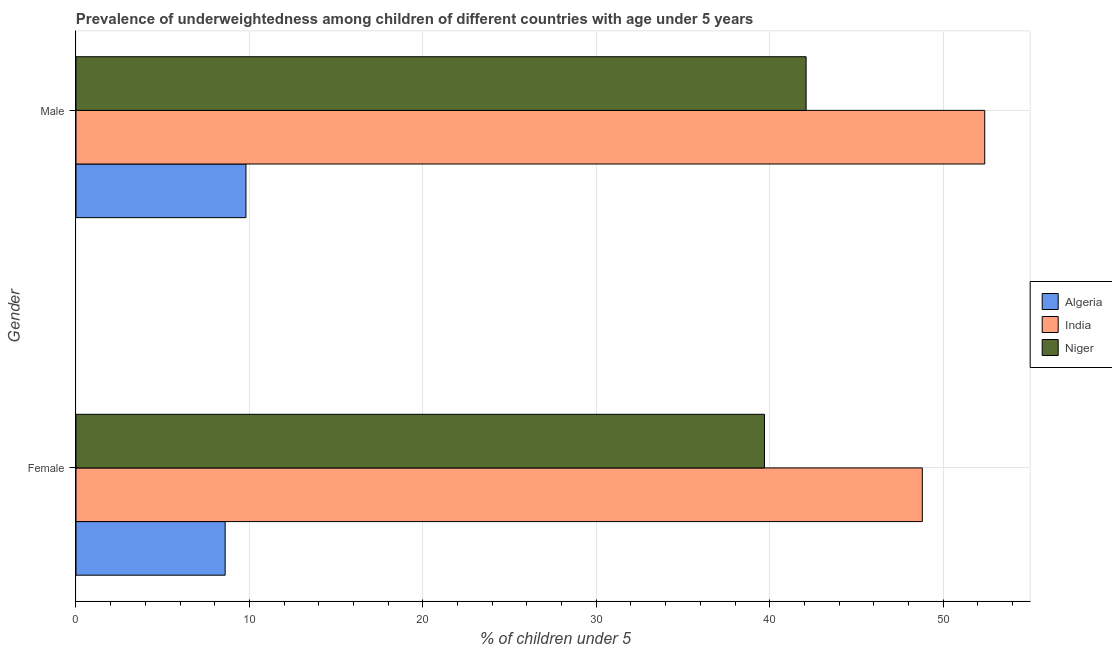How many different coloured bars are there?
Your response must be concise. 3. How many groups of bars are there?
Offer a very short reply. 2. How many bars are there on the 2nd tick from the top?
Offer a terse response. 3. How many bars are there on the 2nd tick from the bottom?
Offer a very short reply. 3. What is the label of the 1st group of bars from the top?
Offer a very short reply. Male. What is the percentage of underweighted male children in India?
Provide a succinct answer. 52.4. Across all countries, what is the maximum percentage of underweighted female children?
Give a very brief answer. 48.8. Across all countries, what is the minimum percentage of underweighted female children?
Offer a very short reply. 8.6. In which country was the percentage of underweighted female children maximum?
Your answer should be very brief. India. In which country was the percentage of underweighted female children minimum?
Your answer should be very brief. Algeria. What is the total percentage of underweighted female children in the graph?
Your answer should be compact. 97.1. What is the difference between the percentage of underweighted male children in Niger and that in India?
Your response must be concise. -10.3. What is the difference between the percentage of underweighted male children in Algeria and the percentage of underweighted female children in Niger?
Provide a succinct answer. -29.9. What is the average percentage of underweighted male children per country?
Ensure brevity in your answer.  34.77. What is the difference between the percentage of underweighted male children and percentage of underweighted female children in Algeria?
Provide a short and direct response. 1.2. In how many countries, is the percentage of underweighted male children greater than 50 %?
Your answer should be compact. 1. What is the ratio of the percentage of underweighted male children in Algeria to that in Niger?
Make the answer very short. 0.23. Is the percentage of underweighted male children in Niger less than that in Algeria?
Offer a very short reply. No. What does the 2nd bar from the bottom in Female represents?
Offer a terse response. India. How many bars are there?
Your answer should be compact. 6. How many countries are there in the graph?
Your answer should be compact. 3. What is the difference between two consecutive major ticks on the X-axis?
Offer a terse response. 10. Does the graph contain grids?
Your response must be concise. Yes. Where does the legend appear in the graph?
Provide a succinct answer. Center right. How many legend labels are there?
Ensure brevity in your answer.  3. How are the legend labels stacked?
Offer a terse response. Vertical. What is the title of the graph?
Provide a succinct answer. Prevalence of underweightedness among children of different countries with age under 5 years. Does "Bulgaria" appear as one of the legend labels in the graph?
Make the answer very short. No. What is the label or title of the X-axis?
Keep it short and to the point.  % of children under 5. What is the label or title of the Y-axis?
Provide a short and direct response. Gender. What is the  % of children under 5 of Algeria in Female?
Offer a very short reply. 8.6. What is the  % of children under 5 in India in Female?
Offer a terse response. 48.8. What is the  % of children under 5 in Niger in Female?
Your answer should be very brief. 39.7. What is the  % of children under 5 of Algeria in Male?
Offer a terse response. 9.8. What is the  % of children under 5 of India in Male?
Your answer should be compact. 52.4. What is the  % of children under 5 in Niger in Male?
Keep it short and to the point. 42.1. Across all Gender, what is the maximum  % of children under 5 of Algeria?
Keep it short and to the point. 9.8. Across all Gender, what is the maximum  % of children under 5 of India?
Provide a succinct answer. 52.4. Across all Gender, what is the maximum  % of children under 5 of Niger?
Provide a short and direct response. 42.1. Across all Gender, what is the minimum  % of children under 5 in Algeria?
Your answer should be compact. 8.6. Across all Gender, what is the minimum  % of children under 5 of India?
Keep it short and to the point. 48.8. Across all Gender, what is the minimum  % of children under 5 of Niger?
Provide a succinct answer. 39.7. What is the total  % of children under 5 of India in the graph?
Offer a very short reply. 101.2. What is the total  % of children under 5 in Niger in the graph?
Provide a short and direct response. 81.8. What is the difference between the  % of children under 5 of Algeria in Female and the  % of children under 5 of India in Male?
Provide a short and direct response. -43.8. What is the difference between the  % of children under 5 in Algeria in Female and the  % of children under 5 in Niger in Male?
Ensure brevity in your answer.  -33.5. What is the average  % of children under 5 of Algeria per Gender?
Provide a succinct answer. 9.2. What is the average  % of children under 5 of India per Gender?
Offer a terse response. 50.6. What is the average  % of children under 5 of Niger per Gender?
Keep it short and to the point. 40.9. What is the difference between the  % of children under 5 in Algeria and  % of children under 5 in India in Female?
Offer a terse response. -40.2. What is the difference between the  % of children under 5 of Algeria and  % of children under 5 of Niger in Female?
Provide a succinct answer. -31.1. What is the difference between the  % of children under 5 in Algeria and  % of children under 5 in India in Male?
Give a very brief answer. -42.6. What is the difference between the  % of children under 5 of Algeria and  % of children under 5 of Niger in Male?
Keep it short and to the point. -32.3. What is the ratio of the  % of children under 5 of Algeria in Female to that in Male?
Your answer should be compact. 0.88. What is the ratio of the  % of children under 5 of India in Female to that in Male?
Ensure brevity in your answer.  0.93. What is the ratio of the  % of children under 5 in Niger in Female to that in Male?
Offer a very short reply. 0.94. What is the difference between the highest and the second highest  % of children under 5 of Algeria?
Your response must be concise. 1.2. What is the difference between the highest and the second highest  % of children under 5 of Niger?
Your answer should be very brief. 2.4. What is the difference between the highest and the lowest  % of children under 5 of India?
Give a very brief answer. 3.6. What is the difference between the highest and the lowest  % of children under 5 of Niger?
Offer a very short reply. 2.4. 